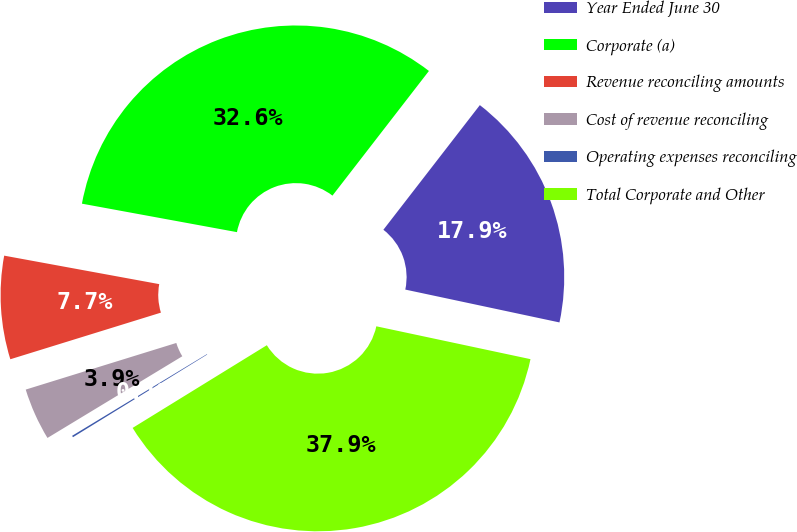Convert chart to OTSL. <chart><loc_0><loc_0><loc_500><loc_500><pie_chart><fcel>Year Ended June 30<fcel>Corporate (a)<fcel>Revenue reconciling amounts<fcel>Cost of revenue reconciling<fcel>Operating expenses reconciling<fcel>Total Corporate and Other<nl><fcel>17.86%<fcel>32.59%<fcel>7.67%<fcel>3.89%<fcel>0.12%<fcel>37.87%<nl></chart> 